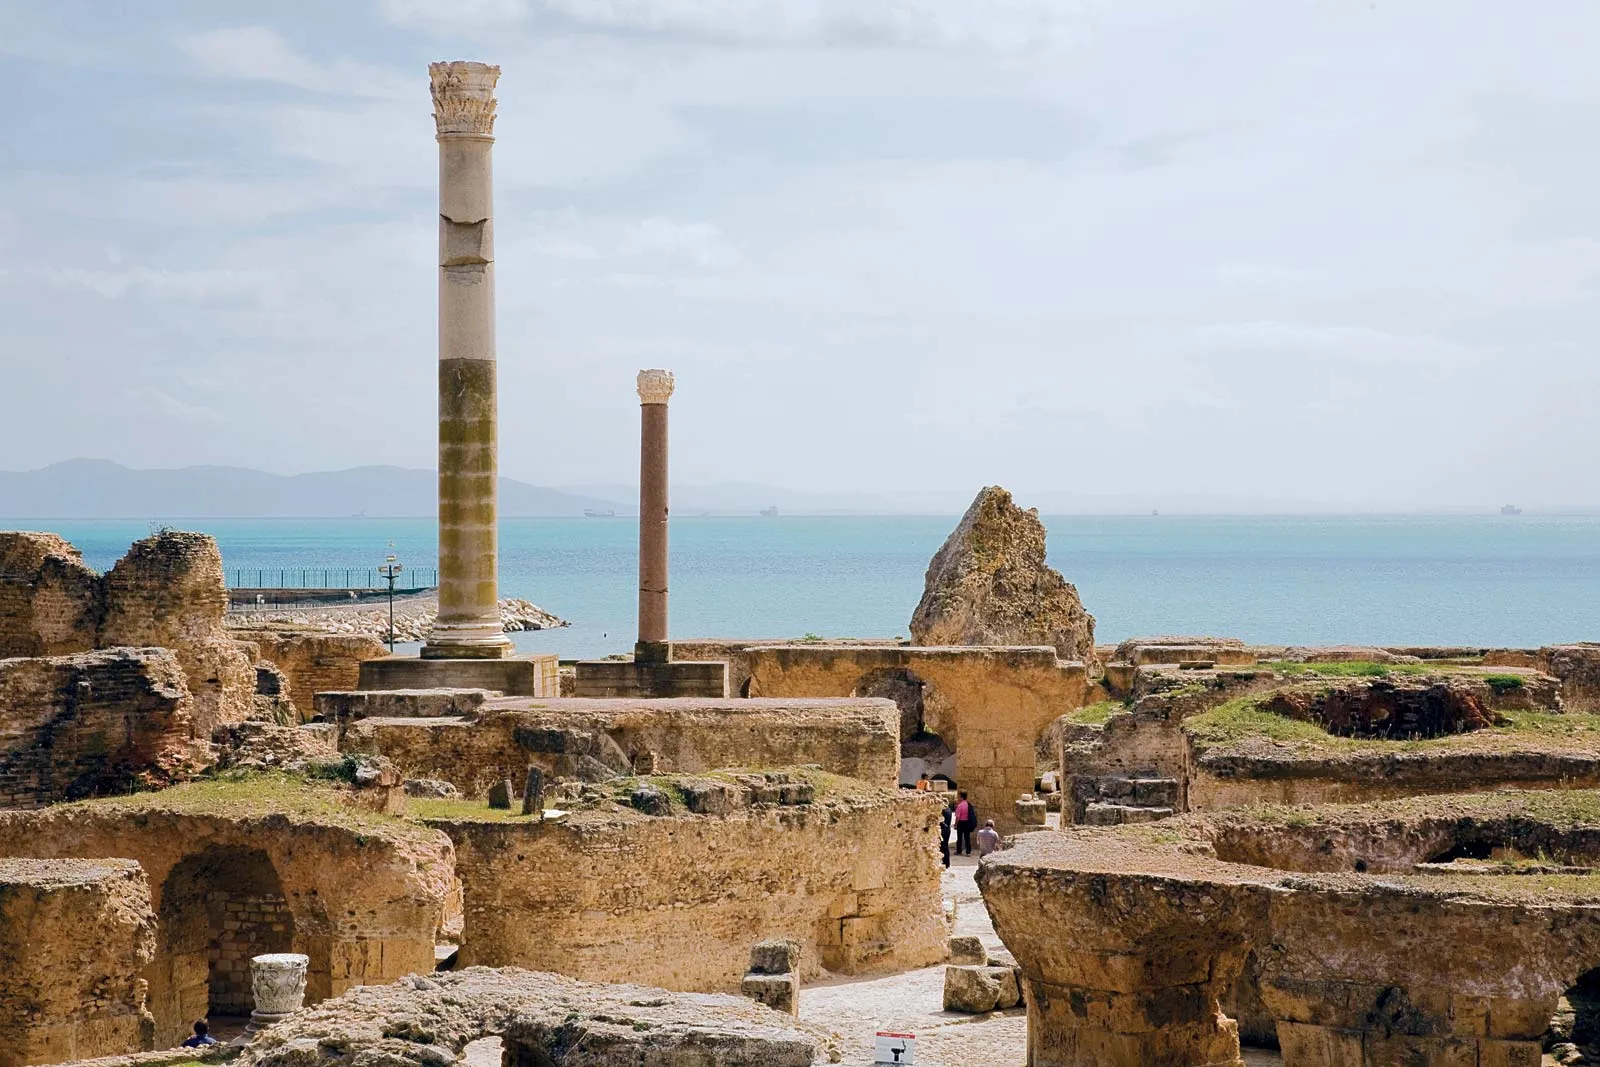Describe the following image. The image features a panoramic view of the ancient ruins of Carthage, nestled against the vivid blue of the Mediterranean Sea near Tunis, Tunisia. Dominating the foreground are the remains of majestic stone columns and scattered masonry, testaments to Carthage's grand past in the ancient world. In the heart of this historical site, several visitors can be seen wandering between the ruins, which scale the size of the columns and stone blocks. The landscape not only captures the historical significance of this UNESCO World Heritage Site but also contrasts the eternal beauty of the crumbling structures with the timeless expanse of the sea. 